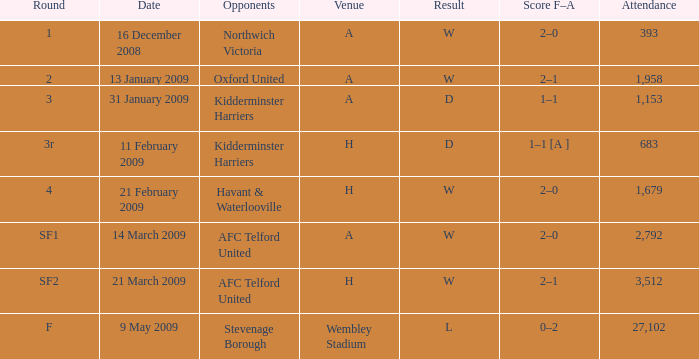What is the round on 21 february 2009? 4.0. 